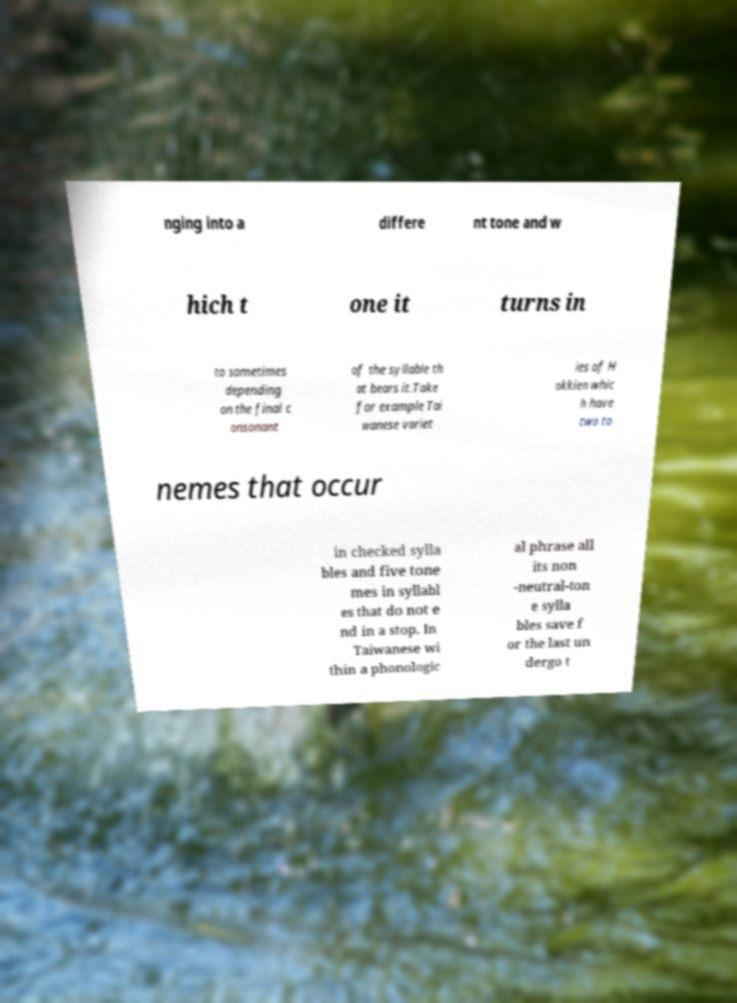Could you assist in decoding the text presented in this image and type it out clearly? nging into a differe nt tone and w hich t one it turns in to sometimes depending on the final c onsonant of the syllable th at bears it.Take for example Tai wanese variet ies of H okkien whic h have two to nemes that occur in checked sylla bles and five tone mes in syllabl es that do not e nd in a stop. In Taiwanese wi thin a phonologic al phrase all its non -neutral-ton e sylla bles save f or the last un dergo t 